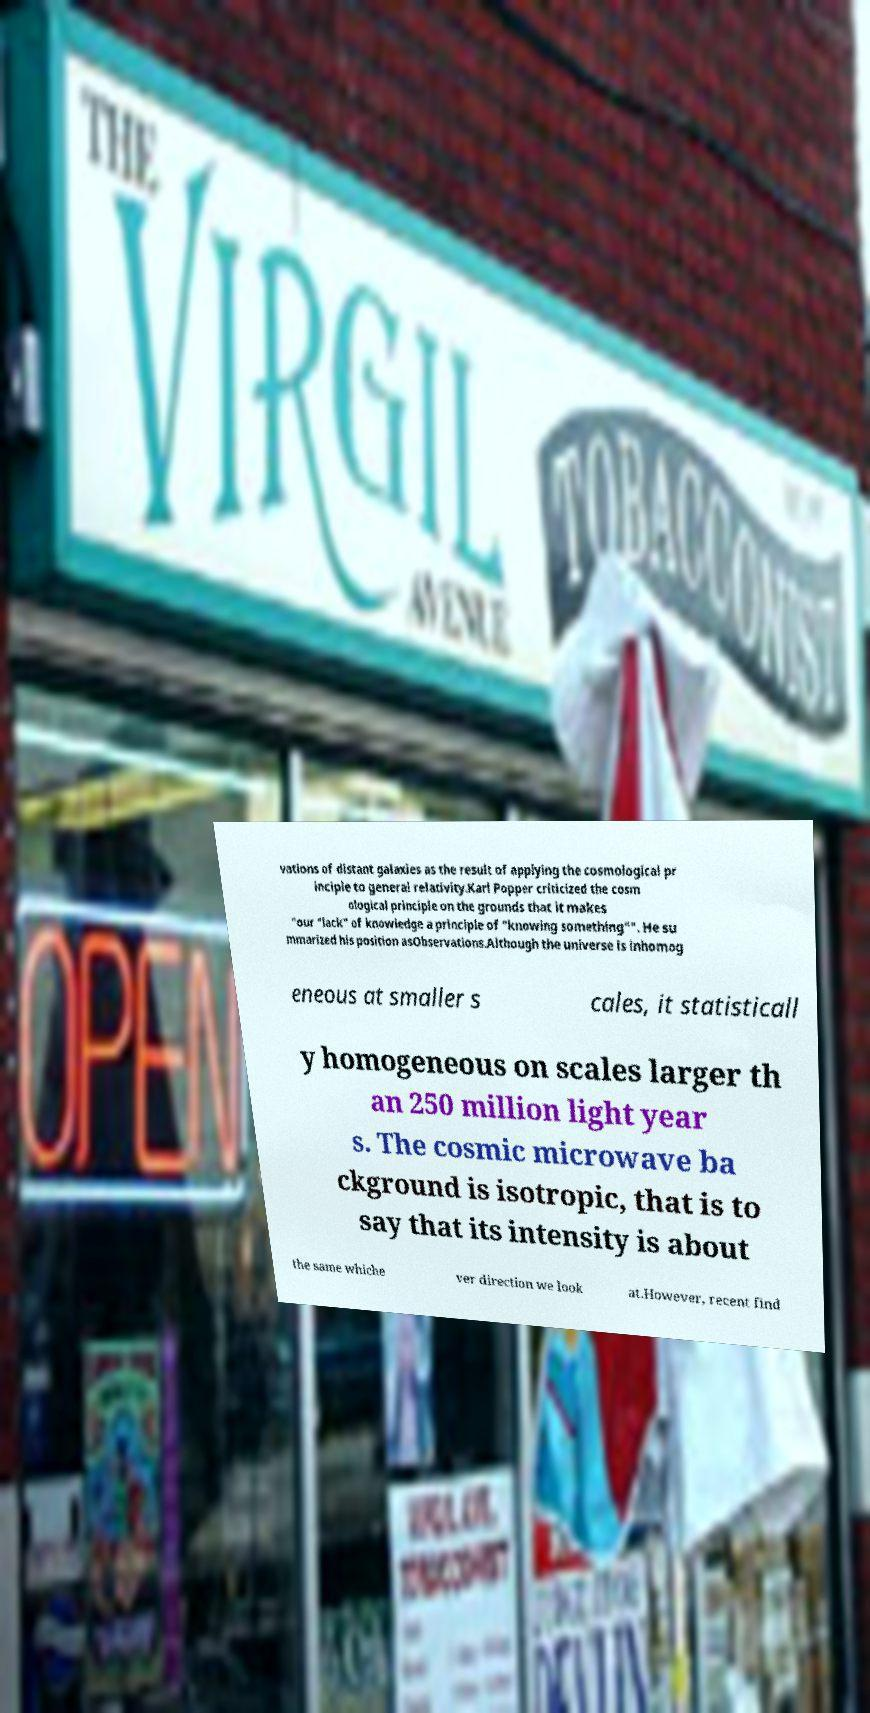Please read and relay the text visible in this image. What does it say? vations of distant galaxies as the result of applying the cosmological pr inciple to general relativity.Karl Popper criticized the cosm ological principle on the grounds that it makes "our "lack" of knowledge a principle of "knowing something"". He su mmarized his position asObservations.Although the universe is inhomog eneous at smaller s cales, it statisticall y homogeneous on scales larger th an 250 million light year s. The cosmic microwave ba ckground is isotropic, that is to say that its intensity is about the same whiche ver direction we look at.However, recent find 